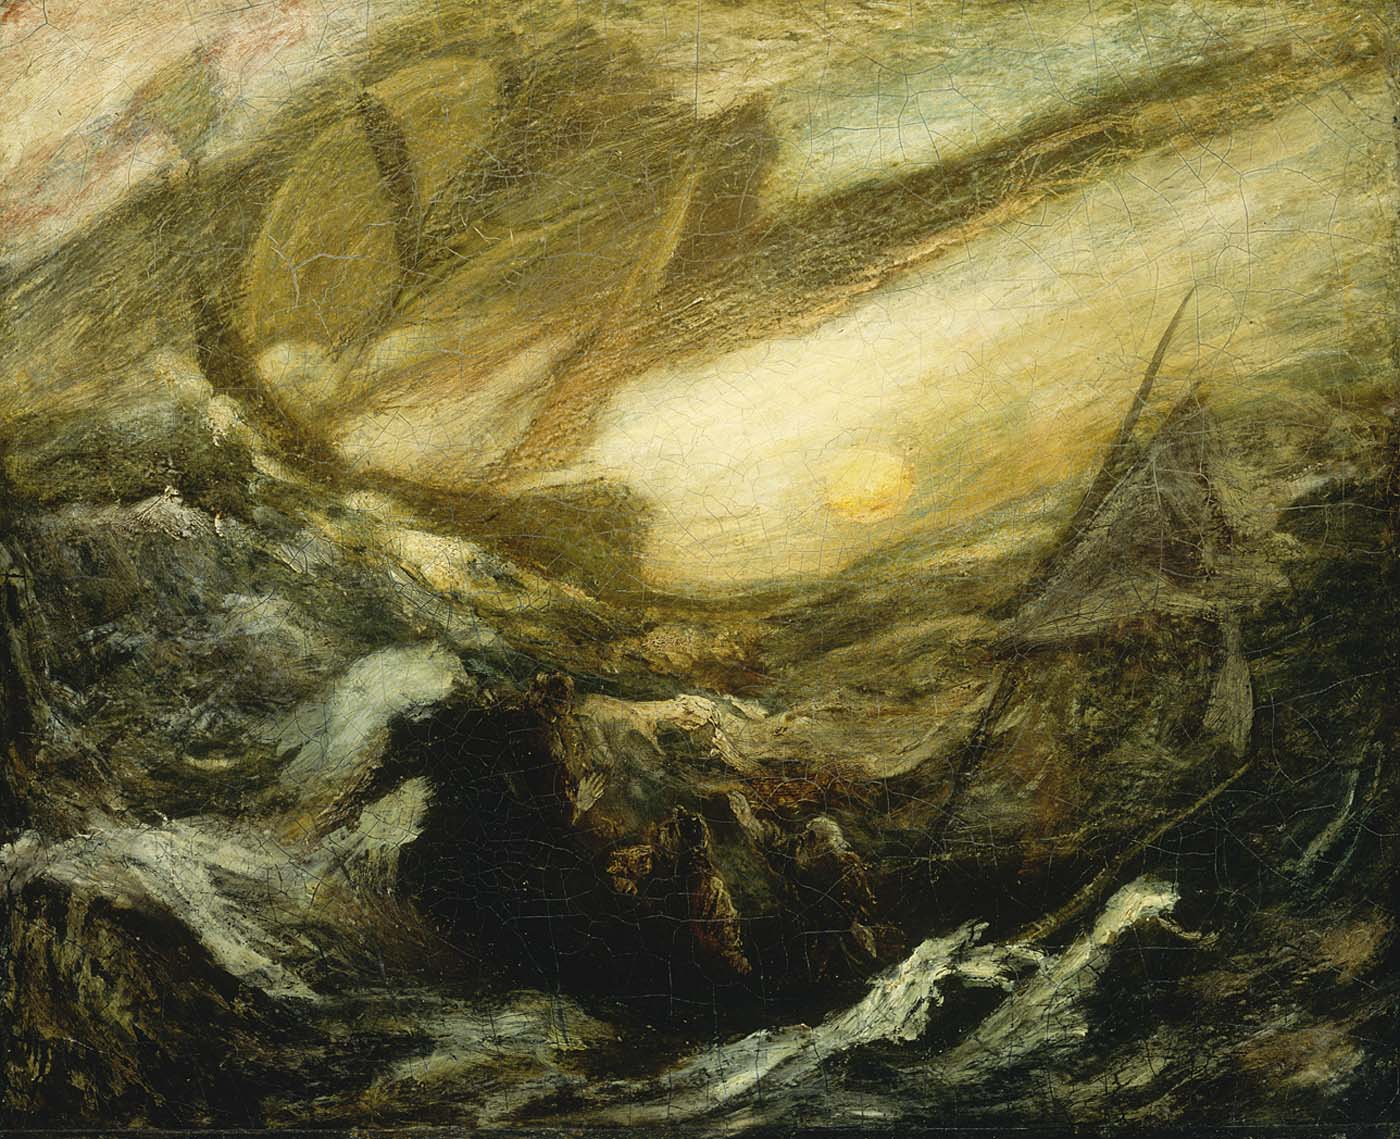How does the artist use color to create impact in this composition? The artist masterfully employs color to create a striking visual impact in this composition. The predominant dark tones of the churning sea and sky set a somber, intense mood, evoking feelings of danger and unease. Against this dark backdrop, the brilliant yellow sun stands out as a focal point, its luminance breaking through the gloom with powerful contrast. This juxtaposition not only draws the viewer's attention but also symbolizes hope and illumination amidst darkness. The earthy greens and browns add depth and texture, contributing to the painting's sense of movement and dynamism. The overall effect is a compelling interplay of light and dark, heightening the emotional resonance of the scene. 